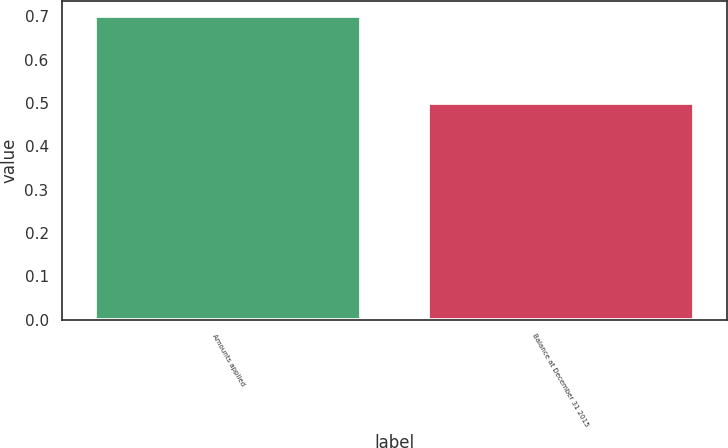<chart> <loc_0><loc_0><loc_500><loc_500><bar_chart><fcel>Amounts applied<fcel>Balance at December 31 2015<nl><fcel>0.7<fcel>0.5<nl></chart> 